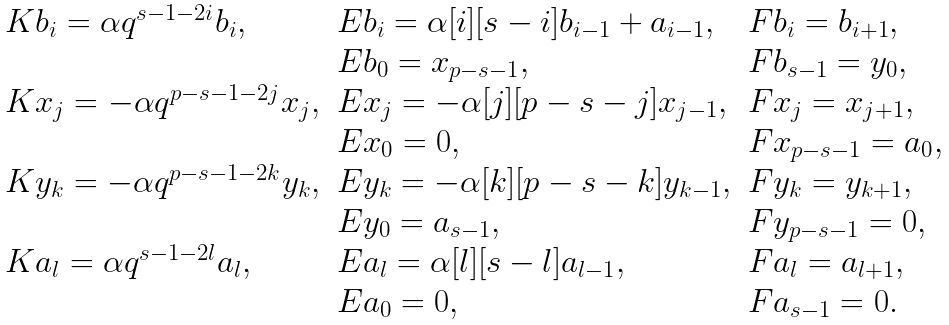<formula> <loc_0><loc_0><loc_500><loc_500>\begin{array} { l l l } K b _ { i } = \alpha q ^ { s - 1 - 2 i } b _ { i } , & E b _ { i } = \alpha [ i ] [ s - i ] b _ { i - 1 } + a _ { i - 1 } , & F b _ { i } = b _ { i + 1 } , \\ & E b _ { 0 } = x _ { p - s - 1 } , & F b _ { s - 1 } = y _ { 0 } , \\ K x _ { j } = - \alpha q ^ { p - s - 1 - 2 j } x _ { j } , & E x _ { j } = - \alpha [ j ] [ p - s - j ] x _ { j - 1 } , & F x _ { j } = x _ { j + 1 } , \\ & E x _ { 0 } = 0 , & F x _ { p - s - 1 } = a _ { 0 } , \\ K y _ { k } = - \alpha q ^ { p - s - 1 - 2 k } y _ { k } , & E y _ { k } = - \alpha [ k ] [ p - s - k ] y _ { k - 1 } , & F y _ { k } = y _ { k + 1 } , \\ & E y _ { 0 } = a _ { s - 1 } , & F y _ { p - s - 1 } = 0 , \\ K a _ { l } = \alpha q ^ { s - 1 - 2 l } a _ { l } , & E a _ { l } = \alpha [ l ] [ s - l ] a _ { l - 1 } , & F a _ { l } = a _ { l + 1 } , \\ & E a _ { 0 } = 0 , & F a _ { s - 1 } = 0 . \end{array}</formula> 